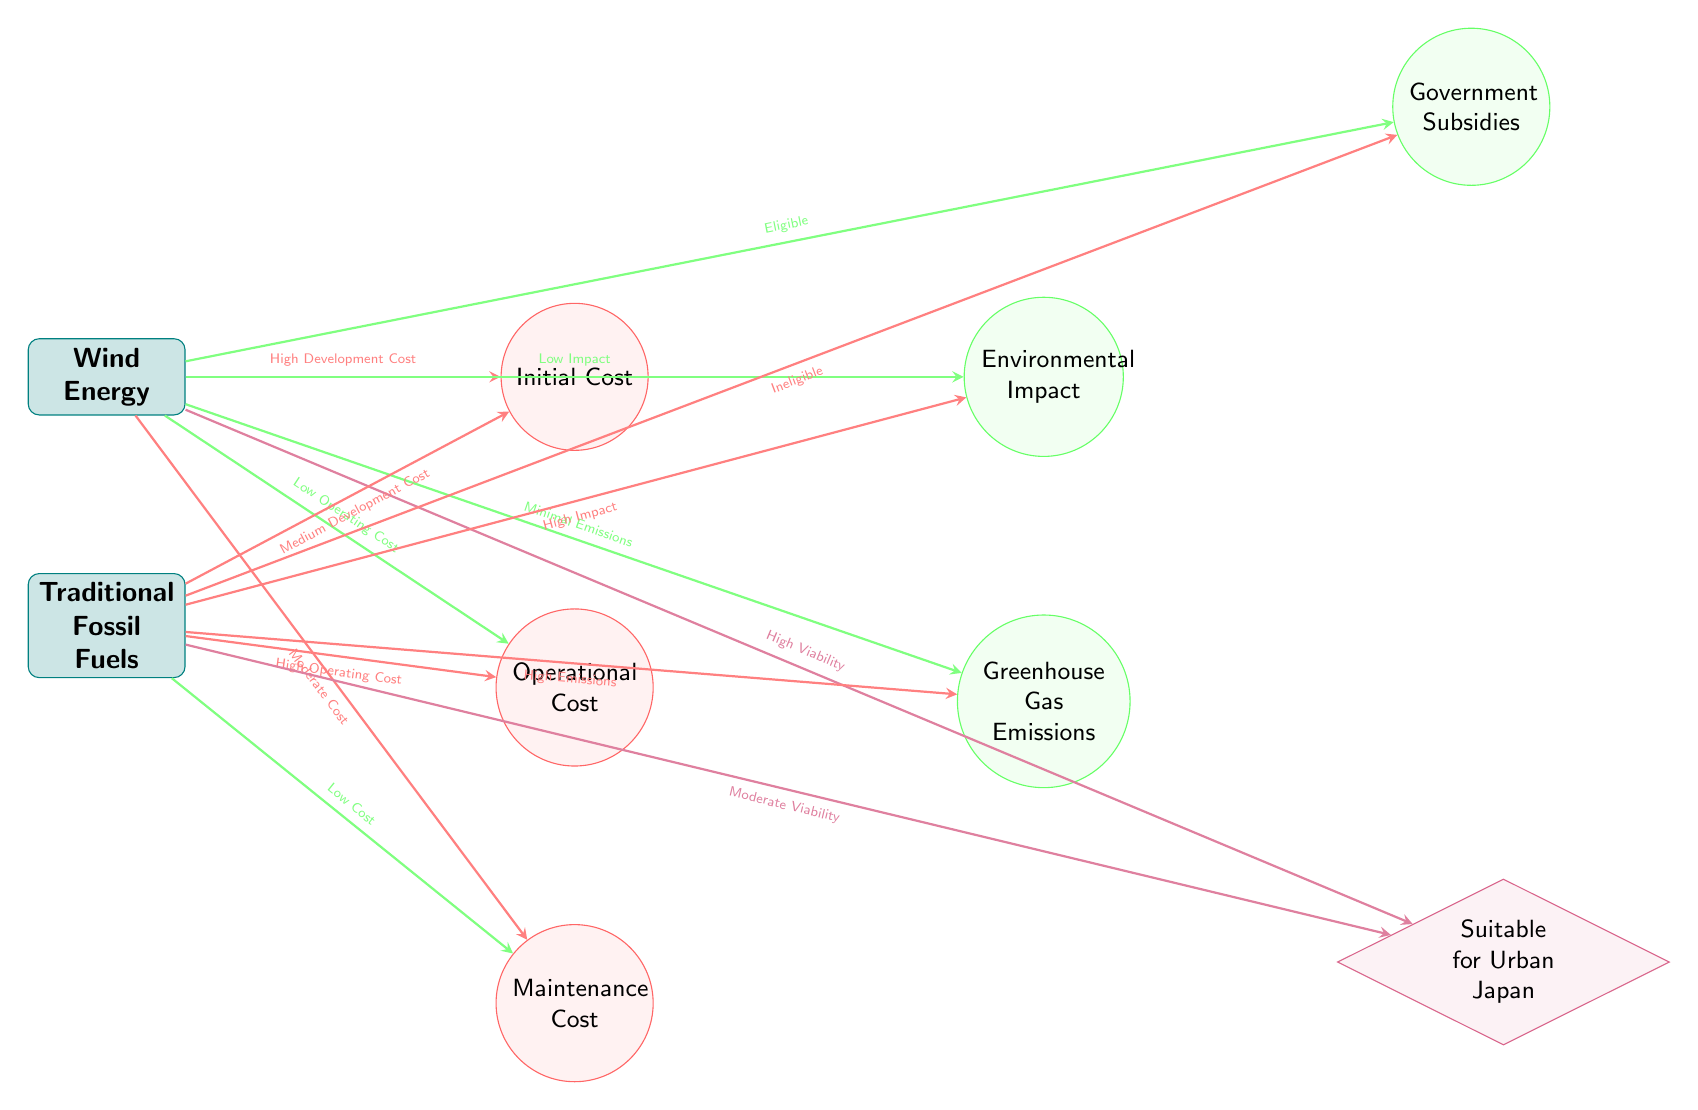What is the initial cost associated with wind energy? The diagram states that the initial cost for wind energy is highlighted under the cost components connected to the wind energy node. The edge from wind energy to initial cost indicates that it has a "High Development Cost," thus the answer is "High Development Cost."
Answer: High Development Cost What is the operational cost for traditional fossil fuels? The operational cost for traditional fossil fuels is specified under the cost components linked to the fossil fuels node. The edge connecting fossil fuels to operational cost indicates it has a "High Operating Cost."
Answer: High Operating Cost How many benefit components are there for wind energy? The benefit components for wind energy can be counted by observing the edges extending from the wind energy node. There are two benefit components connected to wind energy: environmental impact and greenhouse gas emissions. Therefore, the total is 2.
Answer: 2 What type of energy source has minimal emissions? The diagram clearly states that wind energy has a flow labeled "Minimal Emissions" connected to the emissions benefit component. Traditional fossil fuels are indicated to have "High Emissions." Thus the source with minimal emissions is wind energy.
Answer: Wind Energy What indicates that wind energy is eligible for government subsidies? The eligibility for government subsidies in relation to wind energy is marked by the flow from the wind energy node to the subsidies benefit component, where it shows "Eligible." This implies that wind energy qualifies for these subsidies.
Answer: Eligible Which energy source has a lower impact on the environment? By reviewing the benefits of each energy source, the environmental impact is labeled as "Low Impact" for wind energy and "High Impact" for traditional fossil fuels. Therefore, wind energy is the source with a lower impact.
Answer: Wind Energy How does the maintenance cost for fossil fuels compare to wind energy? The maintenance cost for fossil fuels is described as "Low Cost," while for wind energy, it is labeled as "Moderate Cost." This indicates that fossil fuels have a lower maintenance cost compared to wind energy.
Answer: Lower Maintenance Cost What is stated about the viability of fossil fuels in urban Japan? The diagram shows that the fossil fuels node has an edge that leads to the urban context node, stating "Moderate Viability." This informs us about its potential use in urban areas, which is moderate but less favorable compared to wind energy.
Answer: Moderate Viability What is the relationship between wind energy and operating costs? The relationship is shown with an arrow from the wind energy node to the operational cost component, indicating that it has a "Low Operating Cost." This establishes a direct correlation where wind energy is associated with low operational costs.
Answer: Low Operating Cost 